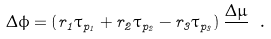<formula> <loc_0><loc_0><loc_500><loc_500>\Delta \phi = \left ( r _ { 1 } \tau _ { p _ { 1 } } + r _ { 2 } \tau _ { p _ { 2 } } - r _ { 3 } \tau _ { p _ { 3 } } \right ) \frac { \Delta \mu } { } \ .</formula> 